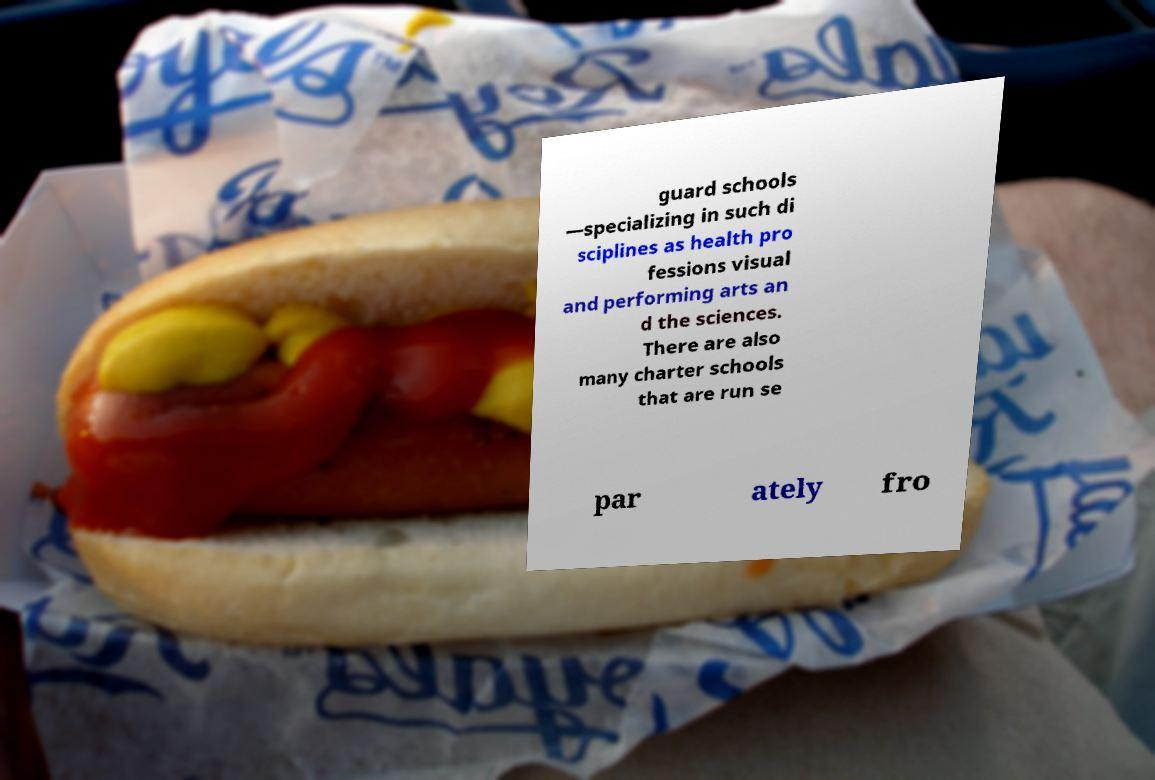Can you accurately transcribe the text from the provided image for me? guard schools —specializing in such di sciplines as health pro fessions visual and performing arts an d the sciences. There are also many charter schools that are run se par ately fro 